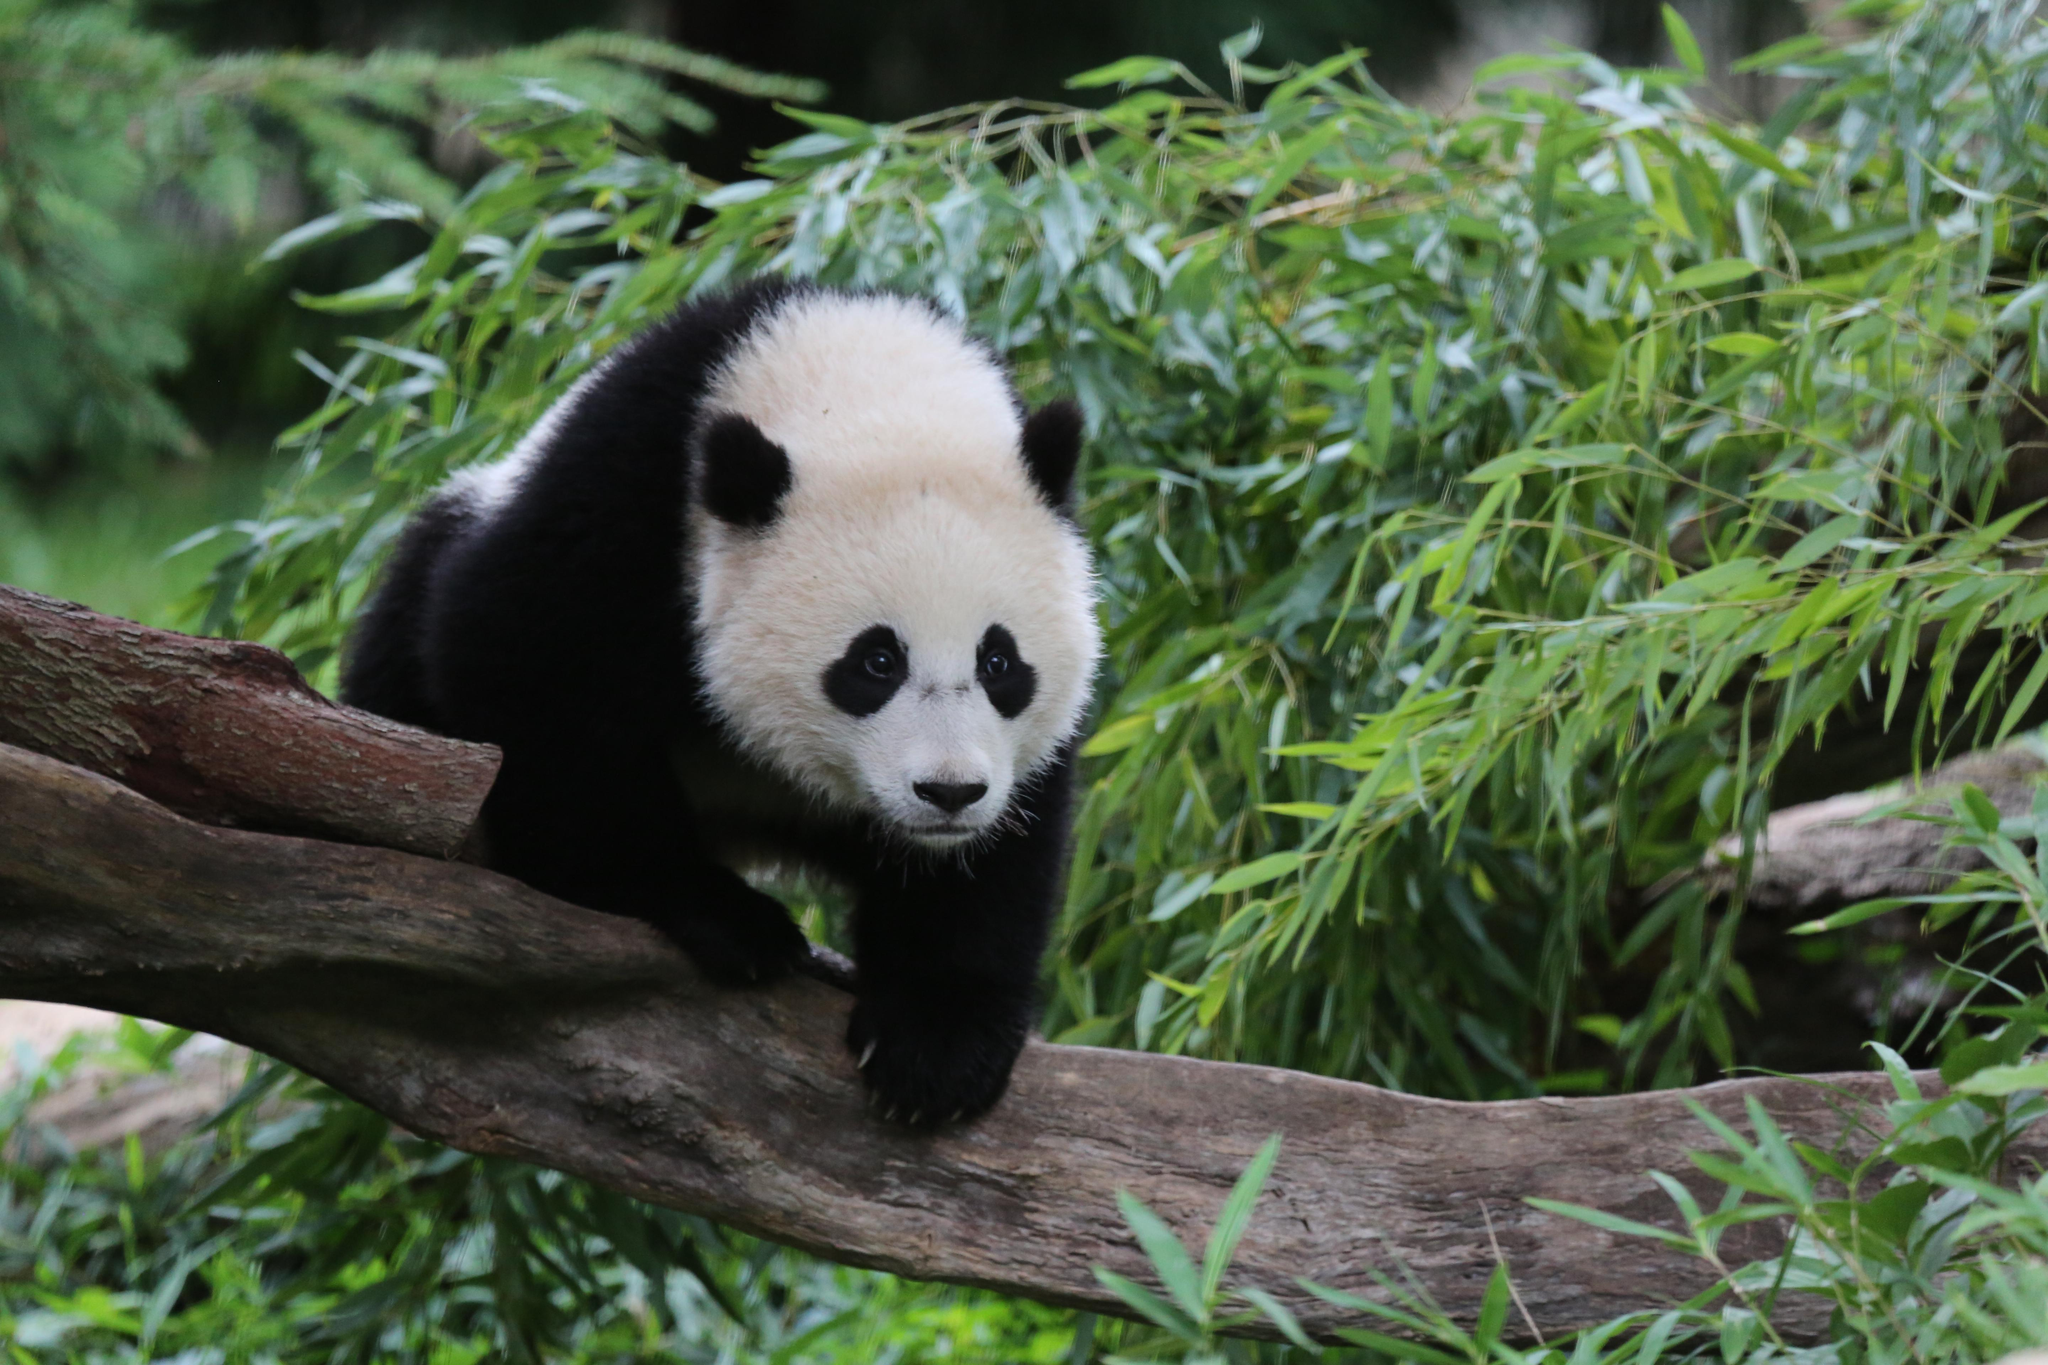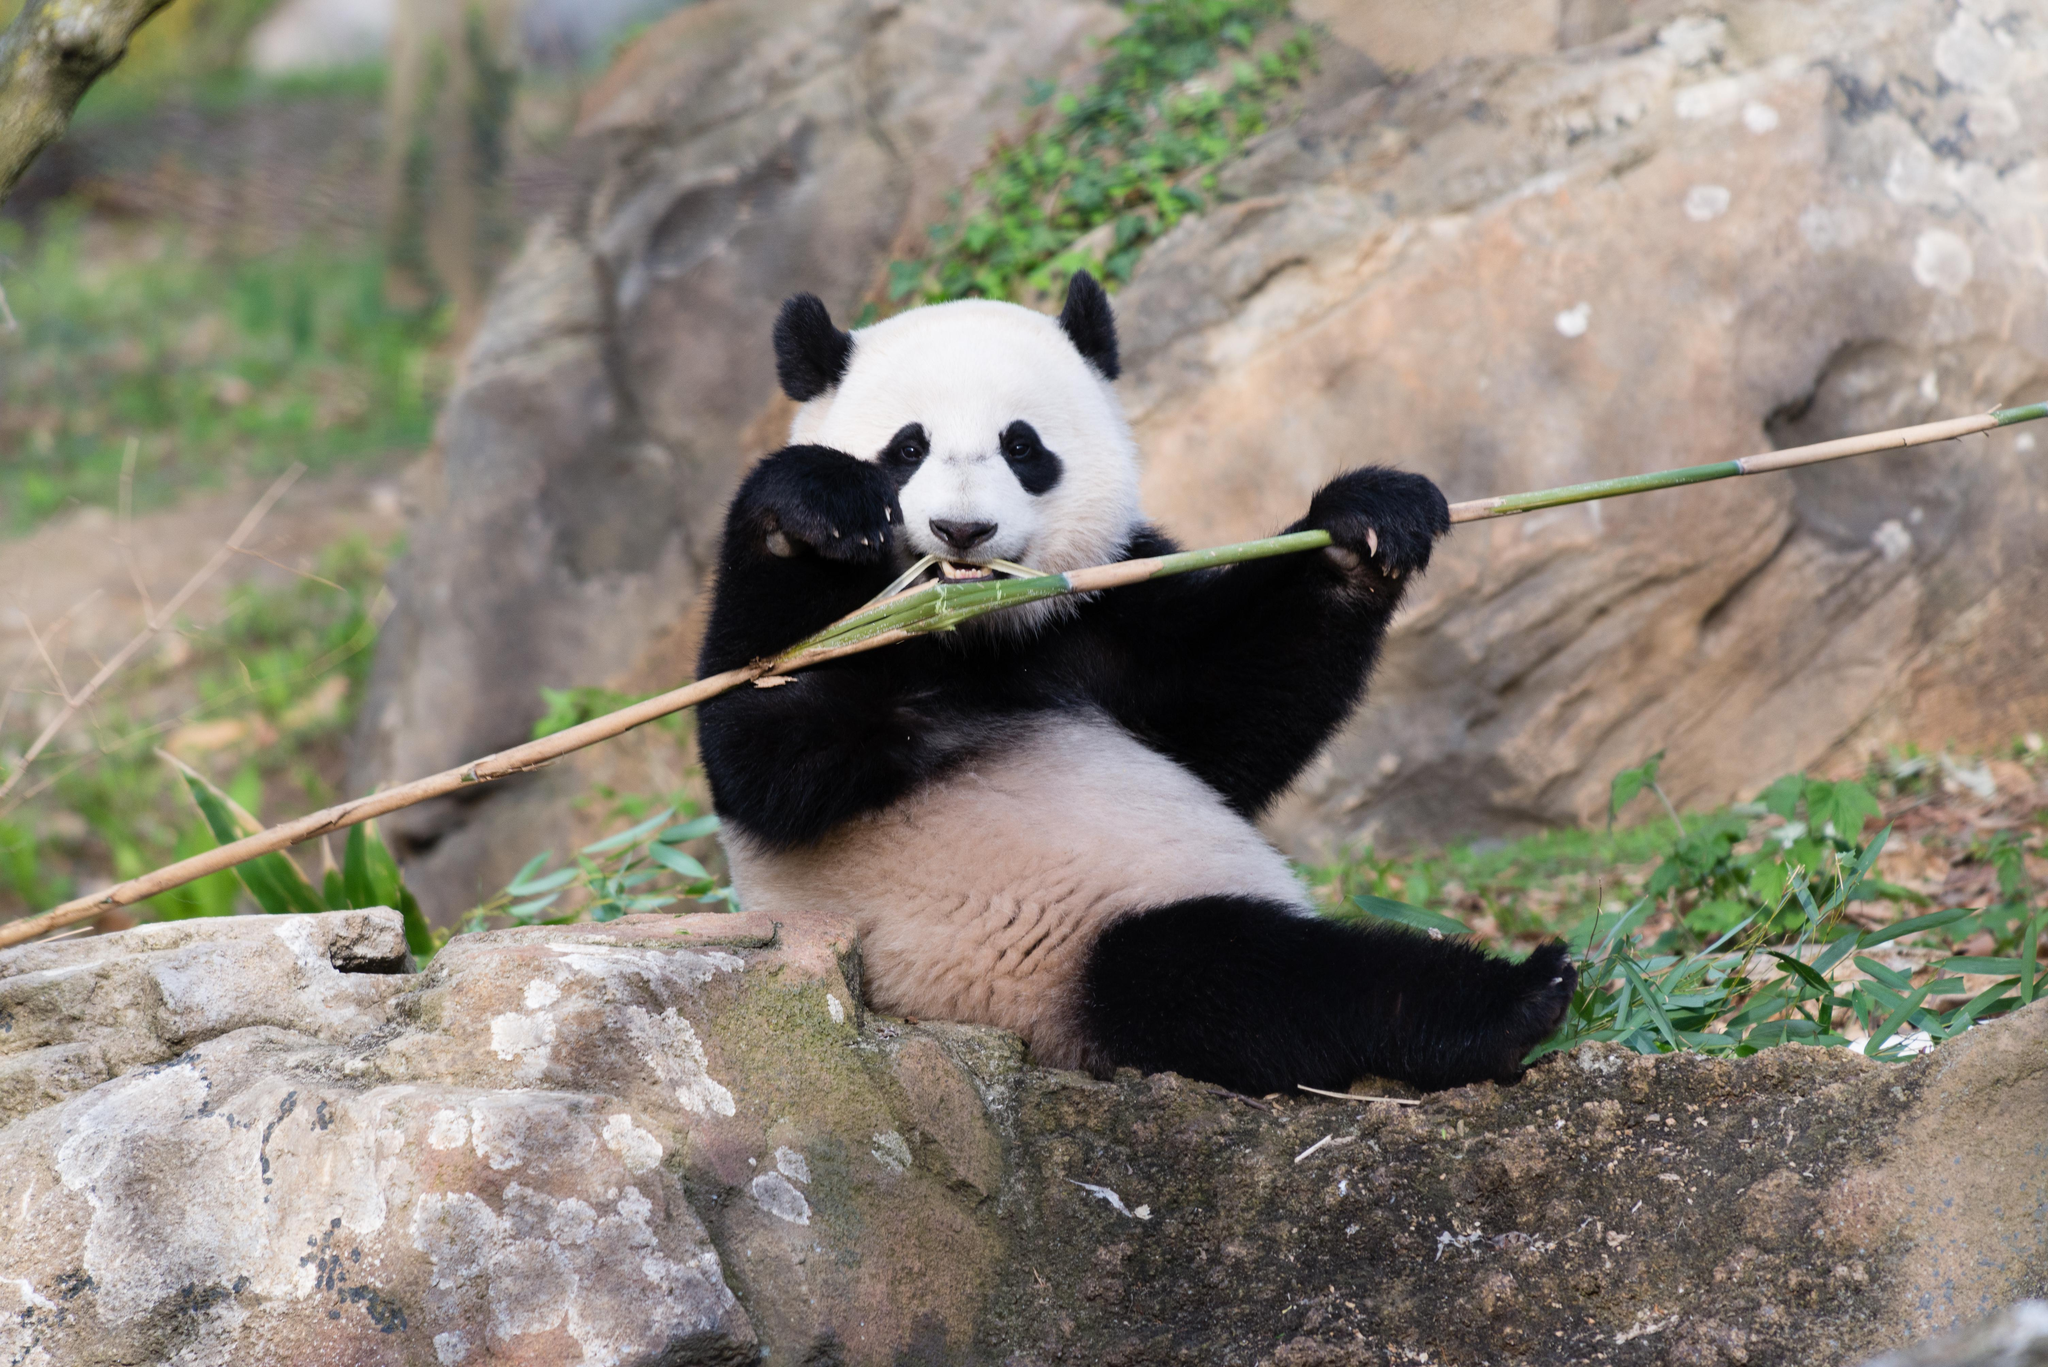The first image is the image on the left, the second image is the image on the right. Given the left and right images, does the statement "The panda in the image on the left is hanging against the side of a tree trunk." hold true? Answer yes or no. No. The first image is the image on the left, the second image is the image on the right. Examine the images to the left and right. Is the description "The right image shows one panda draped over part of a tree, with its hind legs hanging down." accurate? Answer yes or no. No. 